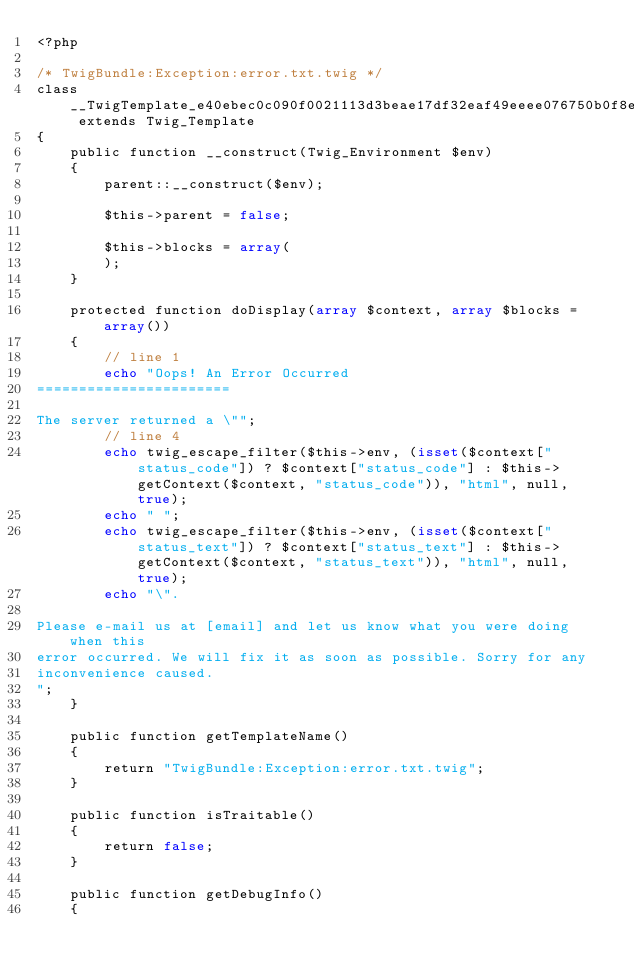<code> <loc_0><loc_0><loc_500><loc_500><_PHP_><?php

/* TwigBundle:Exception:error.txt.twig */
class __TwigTemplate_e40ebec0c090f0021113d3beae17df32eaf49eeee076750b0f8e599f701bcf67 extends Twig_Template
{
    public function __construct(Twig_Environment $env)
    {
        parent::__construct($env);

        $this->parent = false;

        $this->blocks = array(
        );
    }

    protected function doDisplay(array $context, array $blocks = array())
    {
        // line 1
        echo "Oops! An Error Occurred
=======================

The server returned a \"";
        // line 4
        echo twig_escape_filter($this->env, (isset($context["status_code"]) ? $context["status_code"] : $this->getContext($context, "status_code")), "html", null, true);
        echo " ";
        echo twig_escape_filter($this->env, (isset($context["status_text"]) ? $context["status_text"] : $this->getContext($context, "status_text")), "html", null, true);
        echo "\".

Please e-mail us at [email] and let us know what you were doing when this
error occurred. We will fix it as soon as possible. Sorry for any
inconvenience caused.
";
    }

    public function getTemplateName()
    {
        return "TwigBundle:Exception:error.txt.twig";
    }

    public function isTraitable()
    {
        return false;
    }

    public function getDebugInfo()
    {</code> 